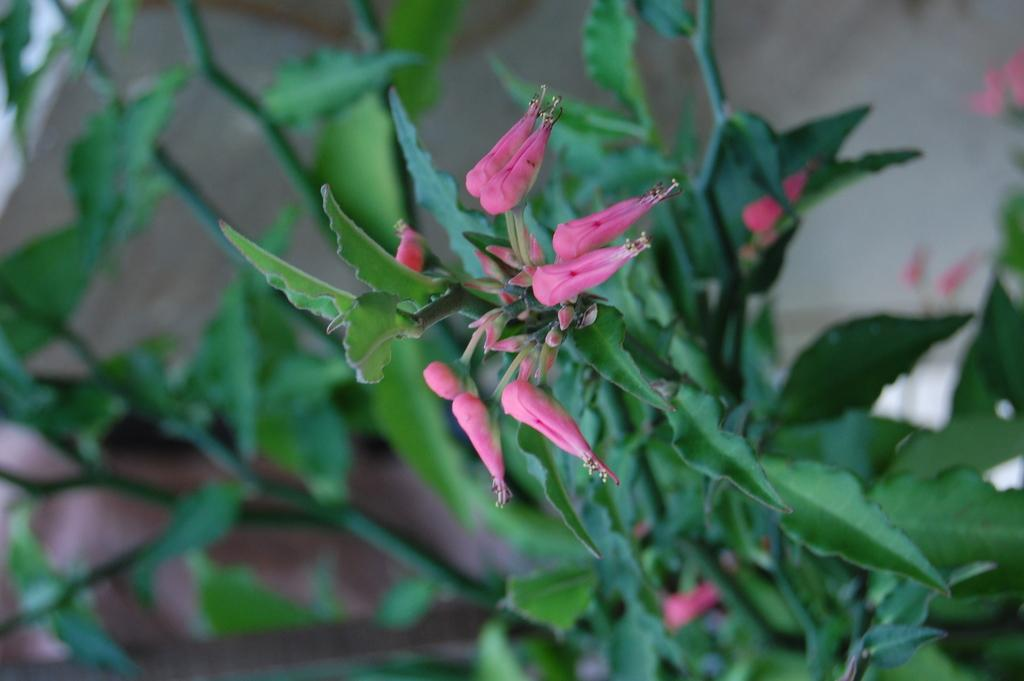What type of living organisms can be seen in the image? Plants can be seen in the image. Are there any specific features of the plants visible in the image? Yes, there are flowers visible in the image. How many eyes can be seen on the plants in the image? Plants do not have eyes, so there are no eyes visible on the plants in the image. What type of furniture is present in the image? There is no furniture present in the image; it features plants and flowers. 